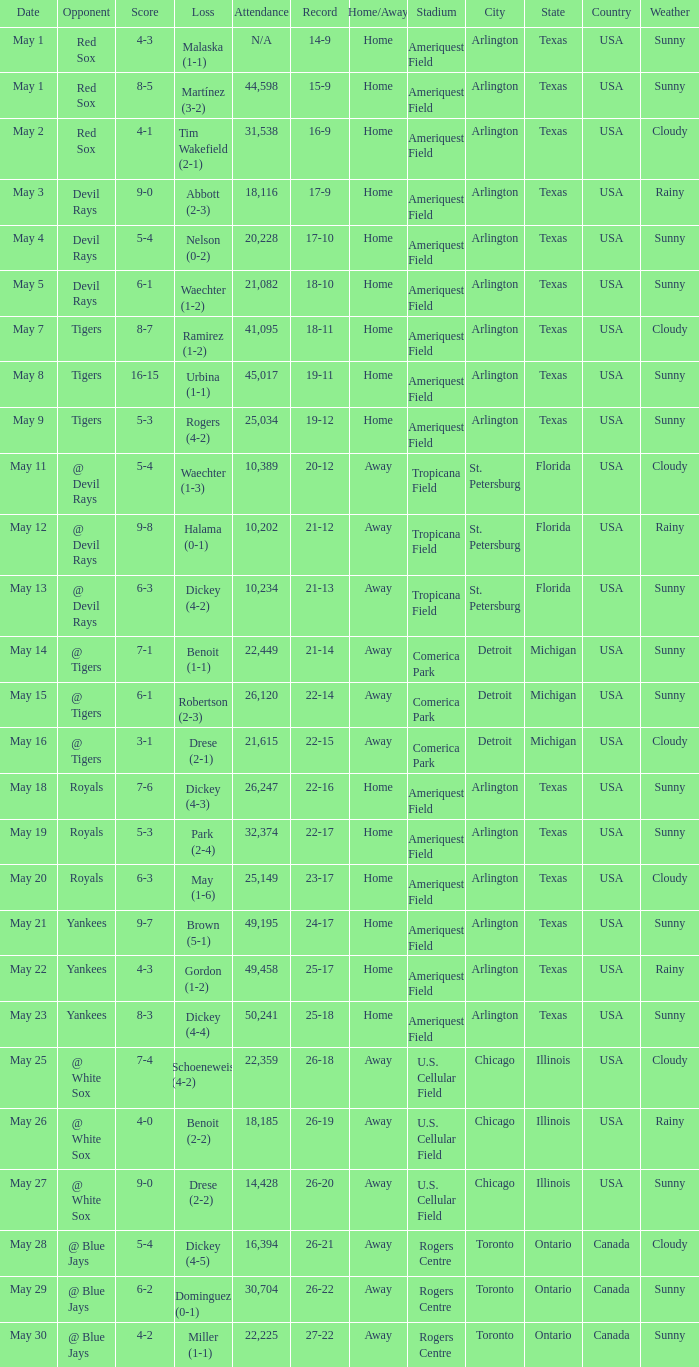What was the record at the game attended by 10,389? 20-12. 